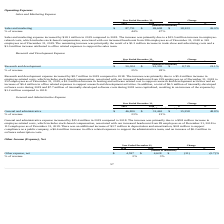According to Everbridge's financial document, What was the decrease in the Other net expense in 2019? Based on the financial document, the answer is $31 thousand. Also, What was the increase in interest income? Based on the financial document, the answer is $2.7 million. Also, What was the % of revenue in 2019 and 2018? The document shows two values: 2 and 3 (percentage). From the document: "Other expense, net $ 4,597 $ 4,628 $ (31) (0.7)% Other expense, net $ 4,597 $ 4,628 $ (31) (0.7)%..." Also, can you calculate: What was the average Other expense, net for 2018 and 2019? To answer this question, I need to perform calculations using the financial data. The calculation is: (4,597 + 4,628) / 2, which equals 4612.5 (in thousands). This is based on the information: "Other expense, net $ 4,597 $ 4,628 $ (31) (0.7)% Other expense, net $ 4,597 $ 4,628 $ (31) (0.7)%..." The key data points involved are: 4,597, 4,628. Additionally, In which year was Other expense, net less than 5,000 thousands? The document shows two values: 2019 and 2018. Locate and analyze the other expenses in row 4. From the document: "2019 2018 $ % 2019 2018 $ %..." Also, can you calculate: What is the change in the % of revenue from 2018 to 2019? Based on the calculation: 2 - 3, the result is -1 (percentage). This is based on the information: "Other expense, net $ 4,597 $ 4,628 $ (31) (0.7)% Other expense, net $ 4,597 $ 4,628 $ (31) (0.7)%..." The key data points involved are: 2, 3. 